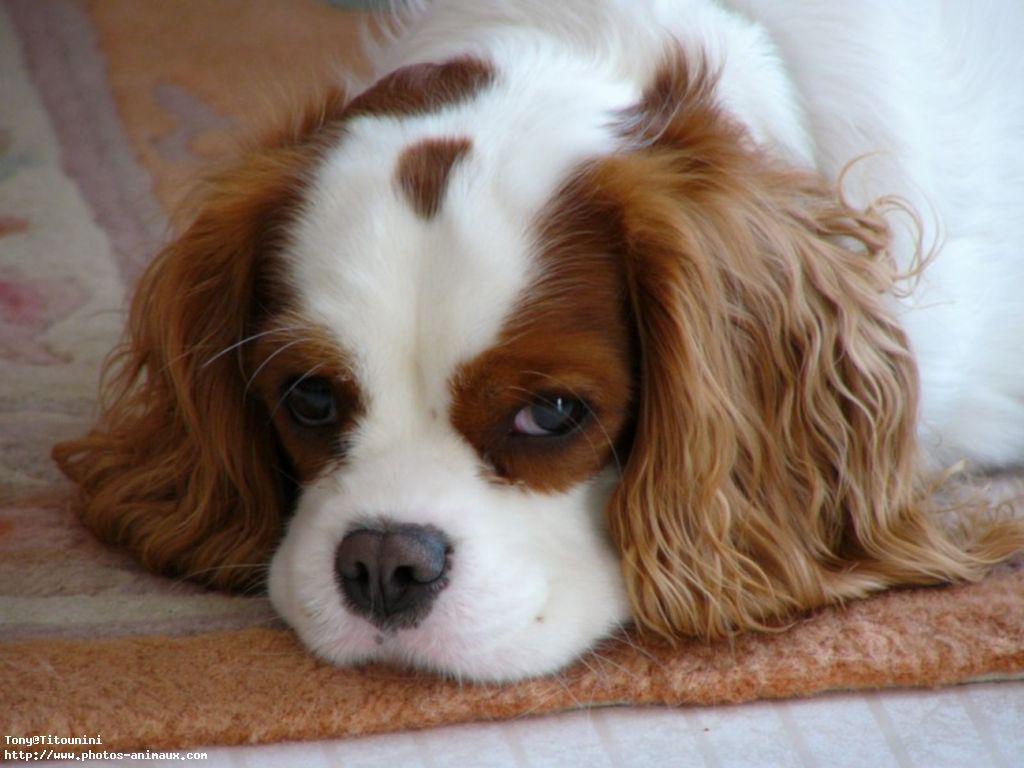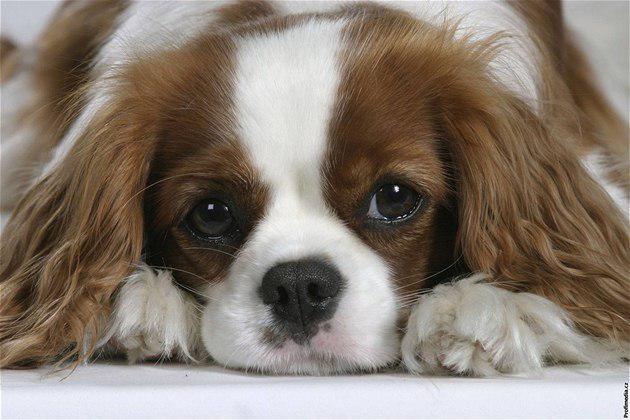The first image is the image on the left, the second image is the image on the right. Given the left and right images, does the statement "There are two Cavalier King Charles Spaniels that are sitting." hold true? Answer yes or no. No. The first image is the image on the left, the second image is the image on the right. Given the left and right images, does the statement "ther is at least one dog on a stone surface with greenery in the background" hold true? Answer yes or no. No. 